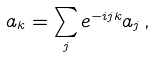Convert formula to latex. <formula><loc_0><loc_0><loc_500><loc_500>a _ { k } = \sum _ { j } e ^ { - i j k } a _ { j } \, ,</formula> 